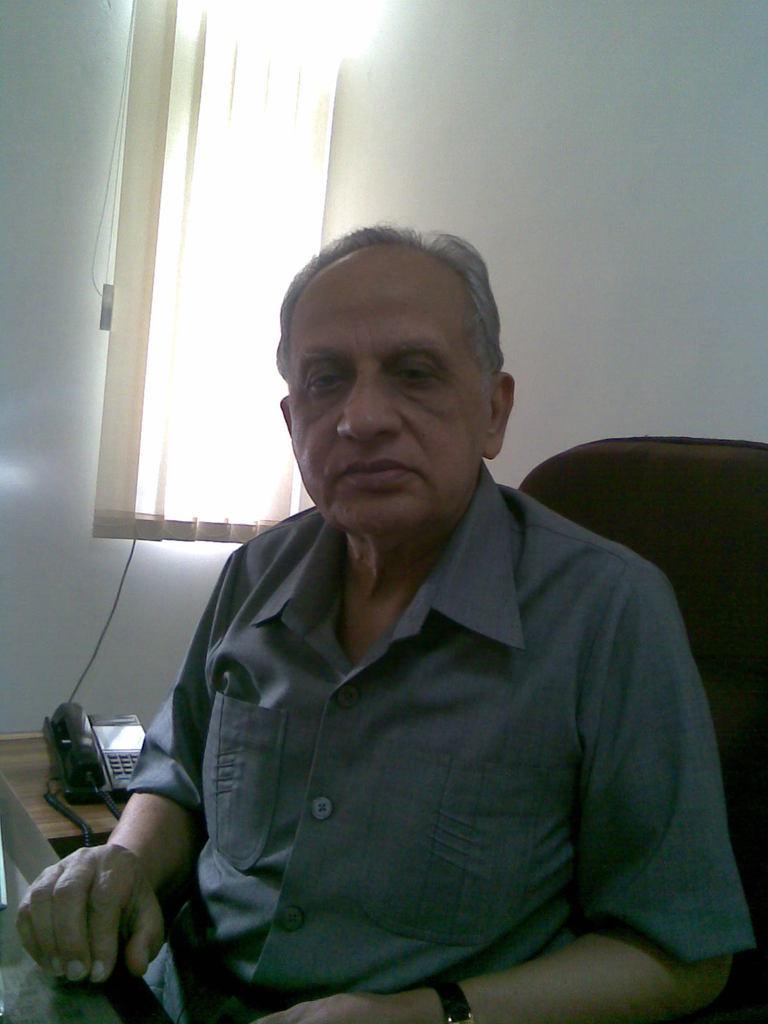What is the person in the image doing? The person is sitting on a chair in the image. What can be seen in the background of the image? There is a wall with a curtain in the background of the image. What furniture is present in the image? There is a table in the image. What object is on the table? There is a phone on the table. What type of guitar is the judge playing in the image? There is no guitar or judge present in the image; it only features a person sitting on a chair, a table, a phone, and a wall with a curtain in the background. 